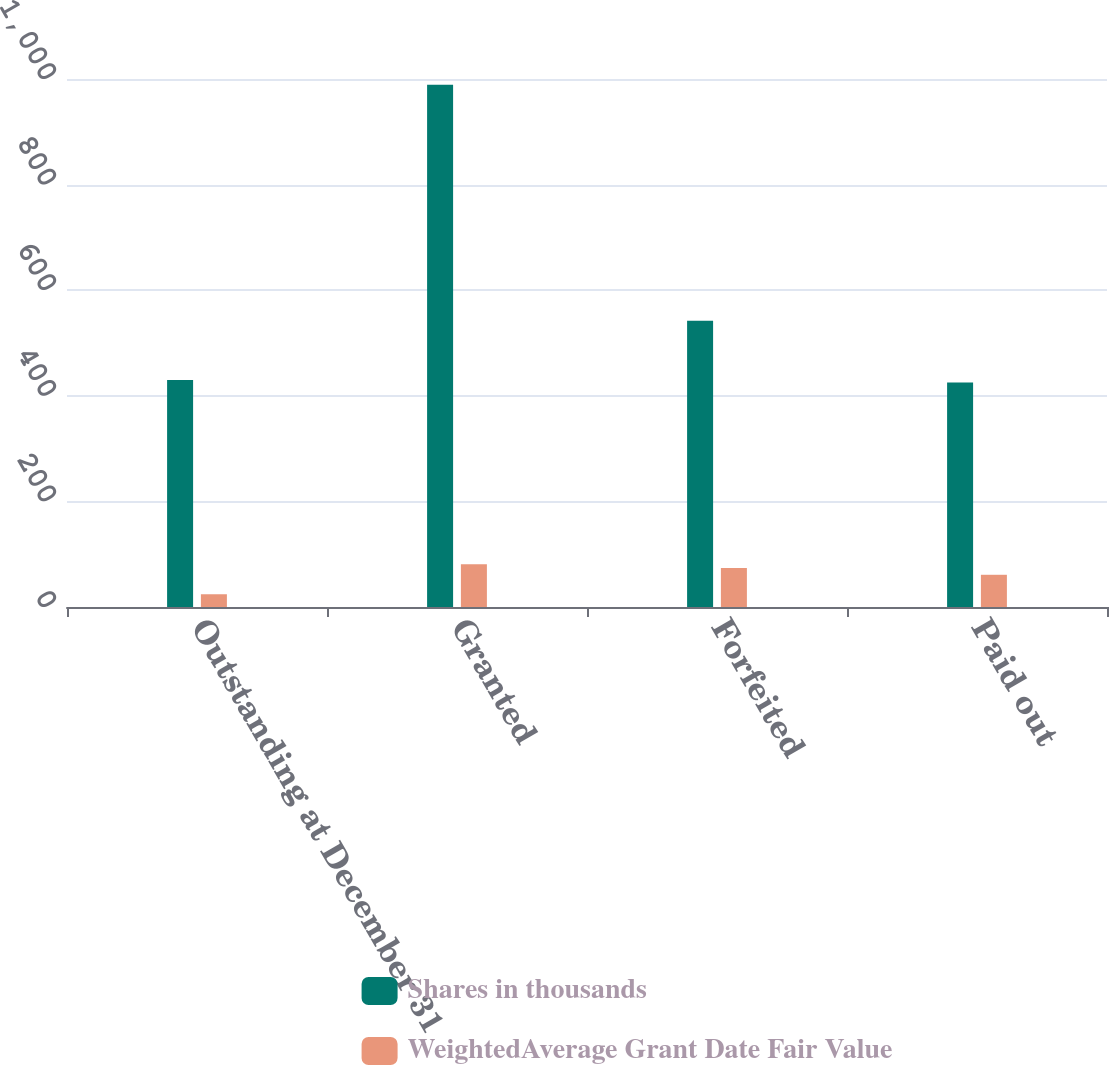<chart> <loc_0><loc_0><loc_500><loc_500><stacked_bar_chart><ecel><fcel>Outstanding at December 31<fcel>Granted<fcel>Forfeited<fcel>Paid out<nl><fcel>Shares in thousands<fcel>430<fcel>989<fcel>542<fcel>425<nl><fcel>WeightedAverage Grant Date Fair Value<fcel>24.14<fcel>80.9<fcel>73.76<fcel>61.02<nl></chart> 